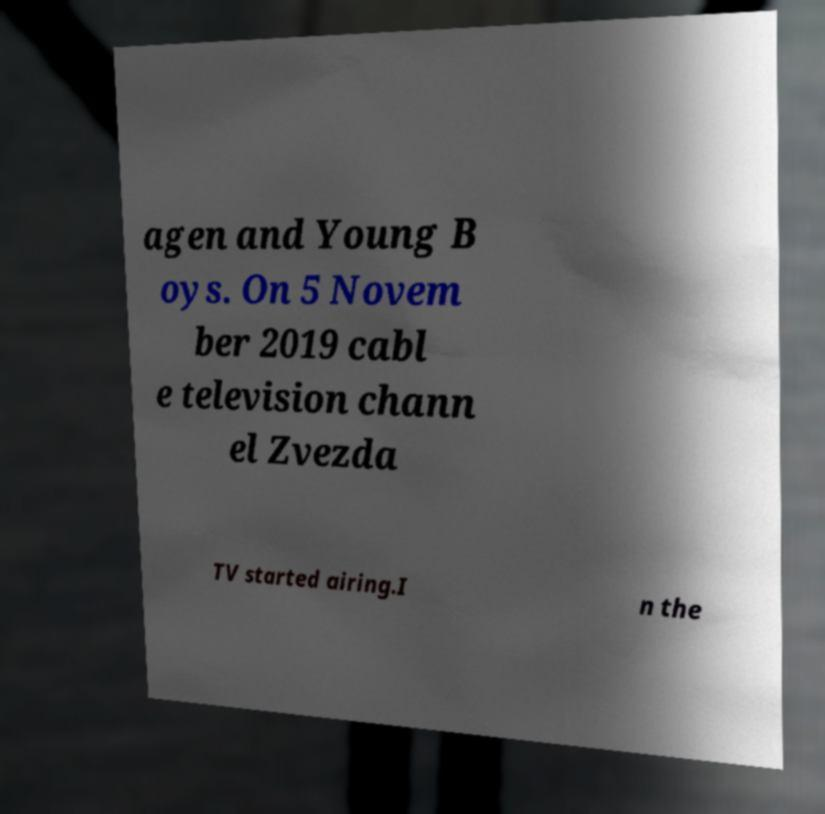For documentation purposes, I need the text within this image transcribed. Could you provide that? agen and Young B oys. On 5 Novem ber 2019 cabl e television chann el Zvezda TV started airing.I n the 